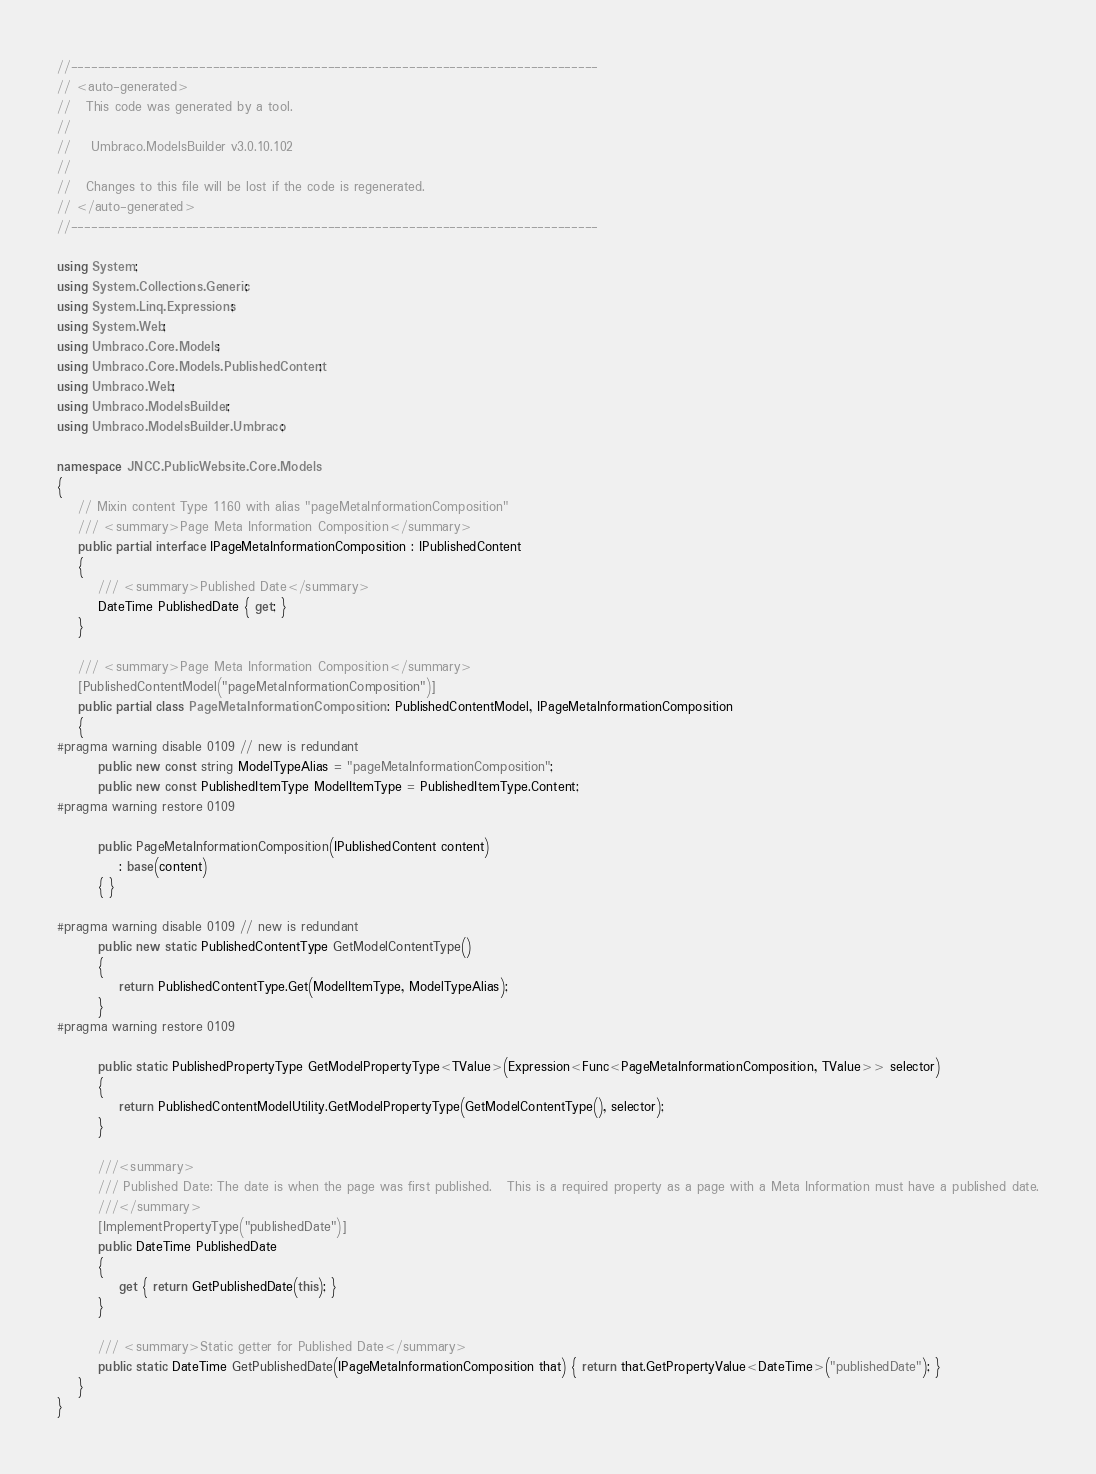<code> <loc_0><loc_0><loc_500><loc_500><_C#_>//------------------------------------------------------------------------------
// <auto-generated>
//   This code was generated by a tool.
//
//    Umbraco.ModelsBuilder v3.0.10.102
//
//   Changes to this file will be lost if the code is regenerated.
// </auto-generated>
//------------------------------------------------------------------------------

using System;
using System.Collections.Generic;
using System.Linq.Expressions;
using System.Web;
using Umbraco.Core.Models;
using Umbraco.Core.Models.PublishedContent;
using Umbraco.Web;
using Umbraco.ModelsBuilder;
using Umbraco.ModelsBuilder.Umbraco;

namespace JNCC.PublicWebsite.Core.Models
{
	// Mixin content Type 1160 with alias "pageMetaInformationComposition"
	/// <summary>Page Meta Information Composition</summary>
	public partial interface IPageMetaInformationComposition : IPublishedContent
	{
		/// <summary>Published Date</summary>
		DateTime PublishedDate { get; }
	}

	/// <summary>Page Meta Information Composition</summary>
	[PublishedContentModel("pageMetaInformationComposition")]
	public partial class PageMetaInformationComposition : PublishedContentModel, IPageMetaInformationComposition
	{
#pragma warning disable 0109 // new is redundant
		public new const string ModelTypeAlias = "pageMetaInformationComposition";
		public new const PublishedItemType ModelItemType = PublishedItemType.Content;
#pragma warning restore 0109

		public PageMetaInformationComposition(IPublishedContent content)
			: base(content)
		{ }

#pragma warning disable 0109 // new is redundant
		public new static PublishedContentType GetModelContentType()
		{
			return PublishedContentType.Get(ModelItemType, ModelTypeAlias);
		}
#pragma warning restore 0109

		public static PublishedPropertyType GetModelPropertyType<TValue>(Expression<Func<PageMetaInformationComposition, TValue>> selector)
		{
			return PublishedContentModelUtility.GetModelPropertyType(GetModelContentType(), selector);
		}

		///<summary>
		/// Published Date: The date is when the page was first published.   This is a required property as a page with a Meta Information must have a published date.
		///</summary>
		[ImplementPropertyType("publishedDate")]
		public DateTime PublishedDate
		{
			get { return GetPublishedDate(this); }
		}

		/// <summary>Static getter for Published Date</summary>
		public static DateTime GetPublishedDate(IPageMetaInformationComposition that) { return that.GetPropertyValue<DateTime>("publishedDate"); }
	}
}
</code> 